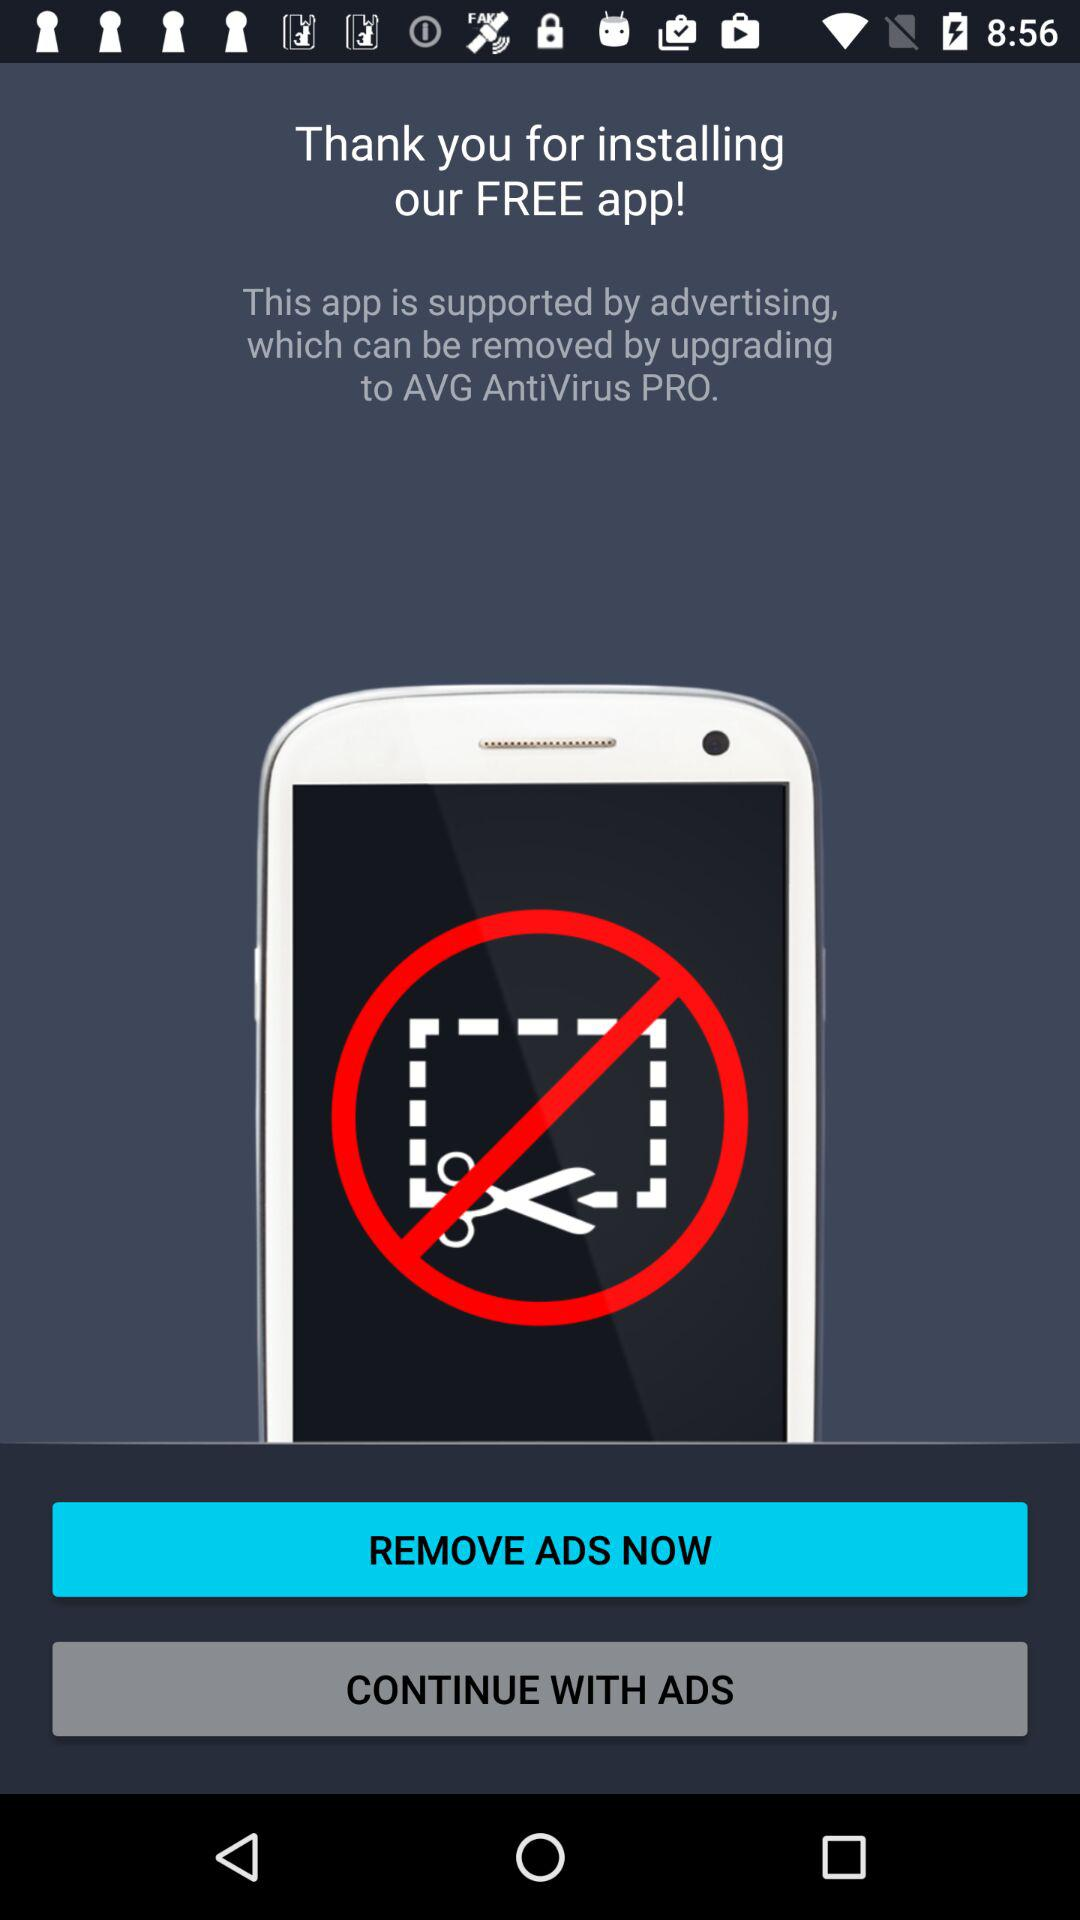Which version of the application is this?
When the provided information is insufficient, respond with <no answer>. <no answer> 